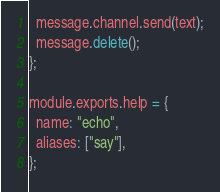<code> <loc_0><loc_0><loc_500><loc_500><_JavaScript_>  message.channel.send(text);
  message.delete();
};

module.exports.help = {
  name: "echo",
  aliases: ["say"],
};
</code> 